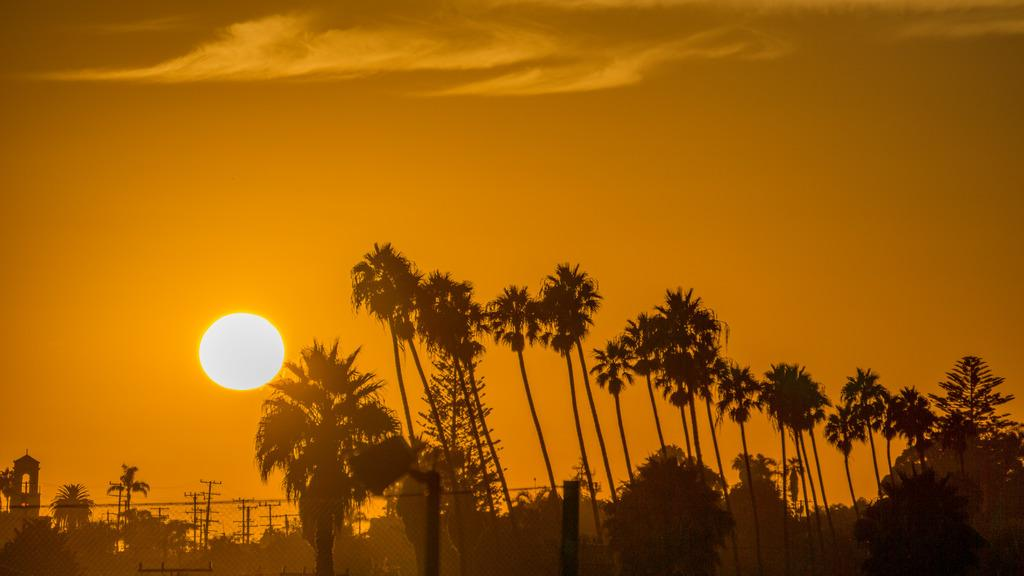What is located at the bottom of the image? There are trees and a building at the bottom of the image. What else can be seen at the bottom of the image? There are poles on the ground at the bottom of the image. What is visible in the background of the image? There are clouds and the sun in the sky in the background of the image. How many people are sleeping on the poles in the image? There are no people present in the image, let alone sleeping on the poles. What shape do the clouds form in the image? The provided facts do not mention the shape of the clouds, so we cannot determine their shape from the image. 